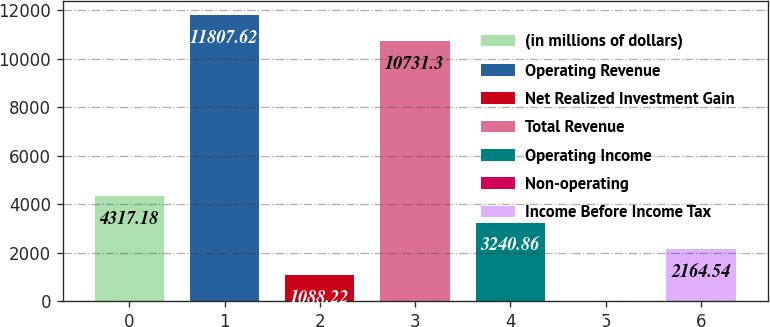<chart> <loc_0><loc_0><loc_500><loc_500><bar_chart><fcel>(in millions of dollars)<fcel>Operating Revenue<fcel>Net Realized Investment Gain<fcel>Total Revenue<fcel>Operating Income<fcel>Non-operating<fcel>Income Before Income Tax<nl><fcel>4317.18<fcel>11807.6<fcel>1088.22<fcel>10731.3<fcel>3240.86<fcel>11.9<fcel>2164.54<nl></chart> 